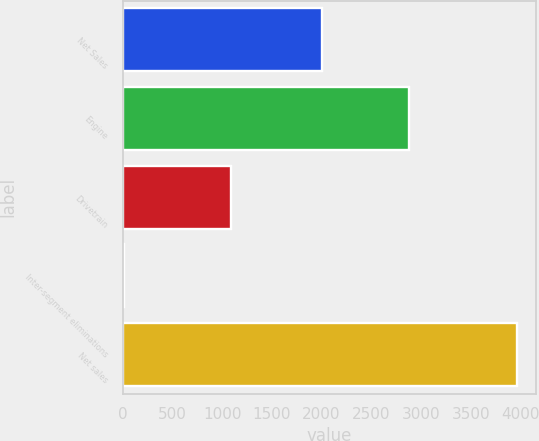Convert chart. <chart><loc_0><loc_0><loc_500><loc_500><bar_chart><fcel>Net Sales<fcel>Engine<fcel>Drivetrain<fcel>Inter-segment eliminations<fcel>Net sales<nl><fcel>2009<fcel>2883.2<fcel>1093.5<fcel>14.9<fcel>3961.8<nl></chart> 